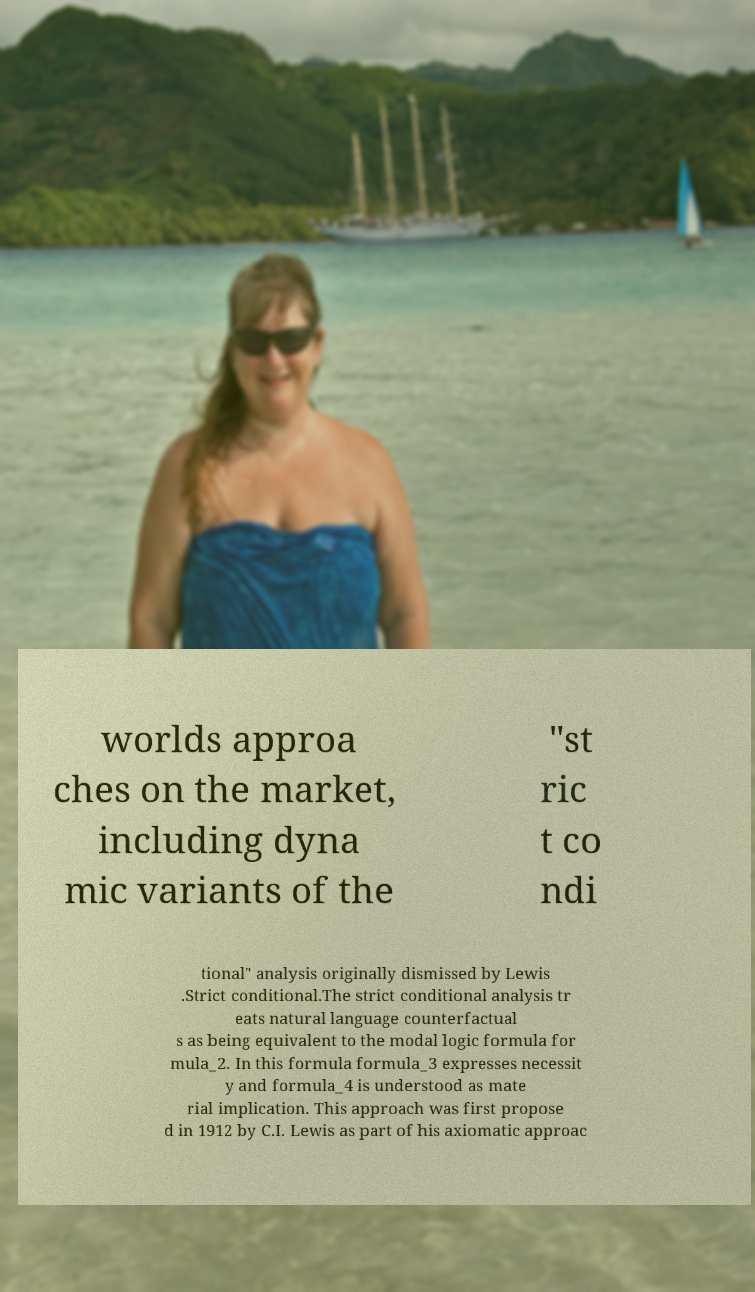Could you assist in decoding the text presented in this image and type it out clearly? worlds approa ches on the market, including dyna mic variants of the "st ric t co ndi tional" analysis originally dismissed by Lewis .Strict conditional.The strict conditional analysis tr eats natural language counterfactual s as being equivalent to the modal logic formula for mula_2. In this formula formula_3 expresses necessit y and formula_4 is understood as mate rial implication. This approach was first propose d in 1912 by C.I. Lewis as part of his axiomatic approac 